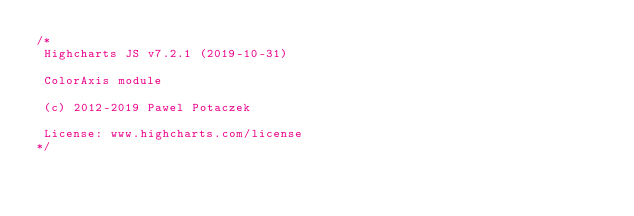Convert code to text. <code><loc_0><loc_0><loc_500><loc_500><_JavaScript_>/*
 Highcharts JS v7.2.1 (2019-10-31)

 ColorAxis module

 (c) 2012-2019 Pawel Potaczek

 License: www.highcharts.com/license
*/</code> 